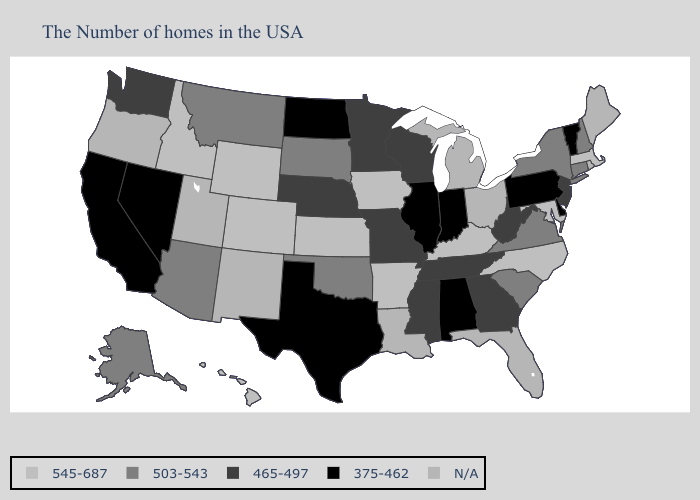What is the value of Arizona?
Concise answer only. 503-543. Name the states that have a value in the range 503-543?
Give a very brief answer. New Hampshire, Connecticut, New York, Virginia, South Carolina, Oklahoma, South Dakota, Montana, Arizona, Alaska. What is the highest value in states that border Indiana?
Write a very short answer. 545-687. Which states hav the highest value in the MidWest?
Answer briefly. Iowa, Kansas. What is the lowest value in states that border Montana?
Short answer required. 375-462. What is the value of Montana?
Give a very brief answer. 503-543. Name the states that have a value in the range 503-543?
Give a very brief answer. New Hampshire, Connecticut, New York, Virginia, South Carolina, Oklahoma, South Dakota, Montana, Arizona, Alaska. Does Kentucky have the highest value in the South?
Short answer required. Yes. Name the states that have a value in the range 465-497?
Quick response, please. New Jersey, West Virginia, Georgia, Tennessee, Wisconsin, Mississippi, Missouri, Minnesota, Nebraska, Washington. What is the lowest value in states that border Michigan?
Answer briefly. 375-462. What is the highest value in the USA?
Give a very brief answer. 545-687. Name the states that have a value in the range 375-462?
Be succinct. Vermont, Delaware, Pennsylvania, Indiana, Alabama, Illinois, Texas, North Dakota, Nevada, California. Name the states that have a value in the range 503-543?
Quick response, please. New Hampshire, Connecticut, New York, Virginia, South Carolina, Oklahoma, South Dakota, Montana, Arizona, Alaska. 